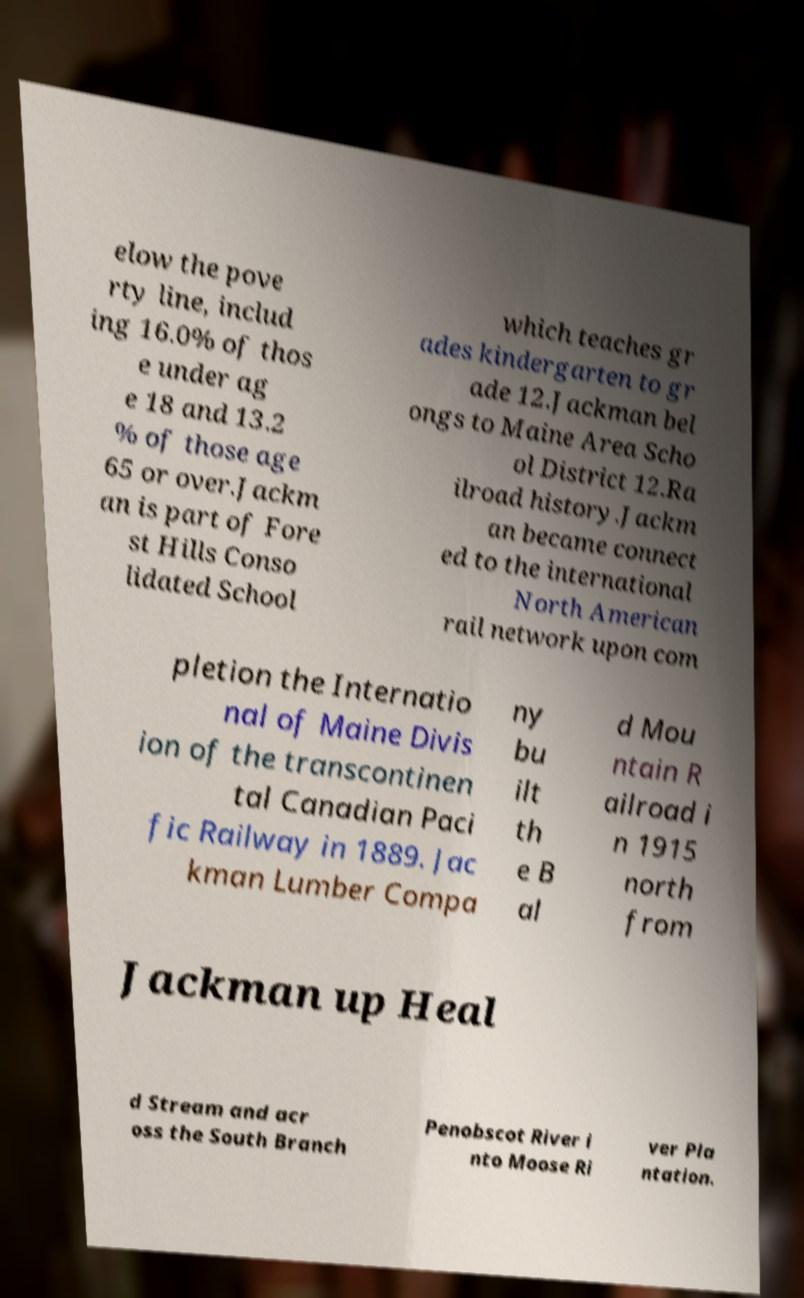For documentation purposes, I need the text within this image transcribed. Could you provide that? elow the pove rty line, includ ing 16.0% of thos e under ag e 18 and 13.2 % of those age 65 or over.Jackm an is part of Fore st Hills Conso lidated School which teaches gr ades kindergarten to gr ade 12.Jackman bel ongs to Maine Area Scho ol District 12.Ra ilroad history.Jackm an became connect ed to the international North American rail network upon com pletion the Internatio nal of Maine Divis ion of the transcontinen tal Canadian Paci fic Railway in 1889. Jac kman Lumber Compa ny bu ilt th e B al d Mou ntain R ailroad i n 1915 north from Jackman up Heal d Stream and acr oss the South Branch Penobscot River i nto Moose Ri ver Pla ntation. 